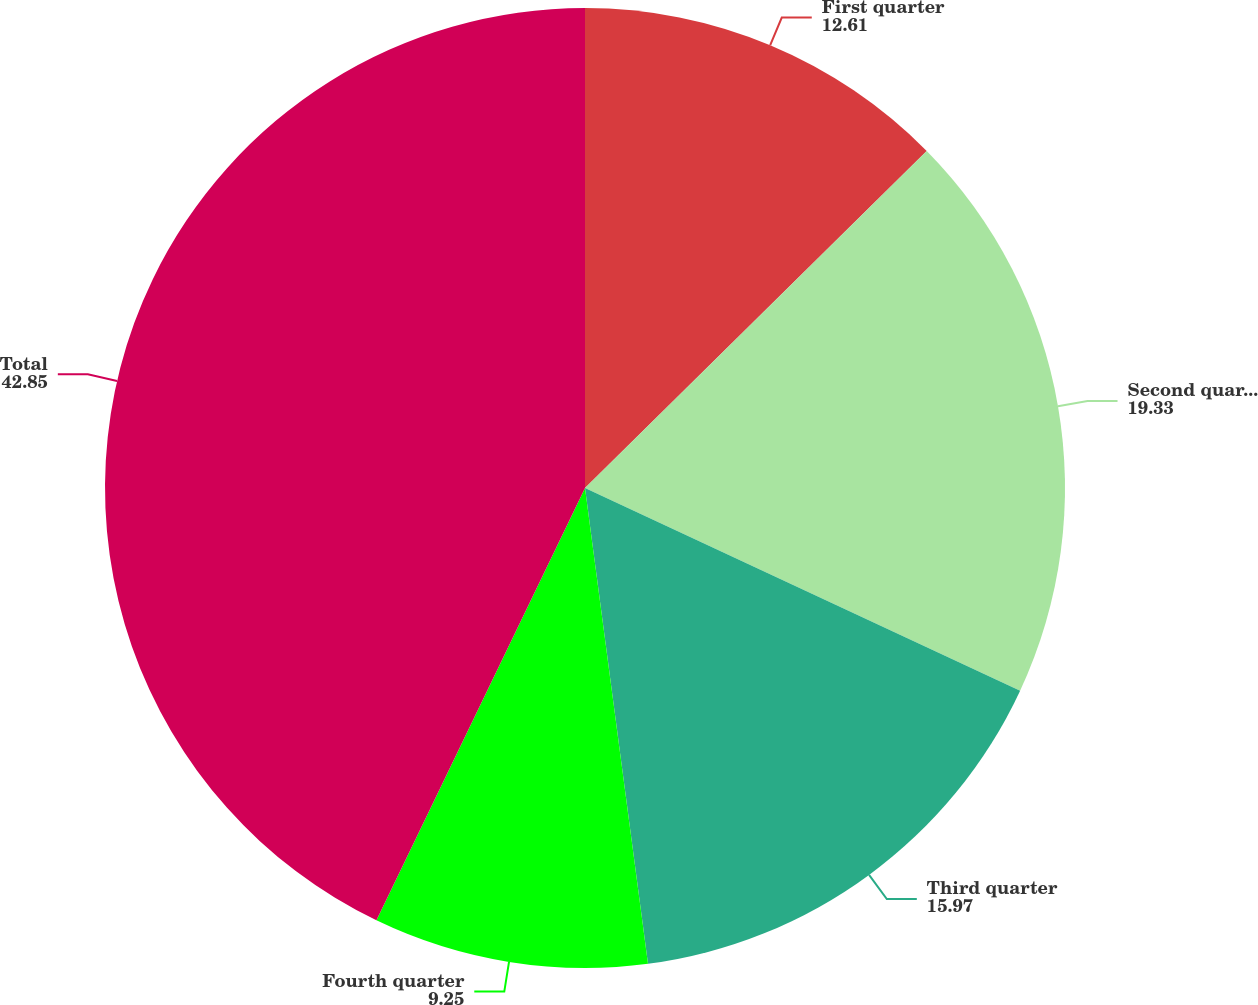Convert chart to OTSL. <chart><loc_0><loc_0><loc_500><loc_500><pie_chart><fcel>First quarter<fcel>Second quarter<fcel>Third quarter<fcel>Fourth quarter<fcel>Total<nl><fcel>12.61%<fcel>19.33%<fcel>15.97%<fcel>9.25%<fcel>42.85%<nl></chart> 